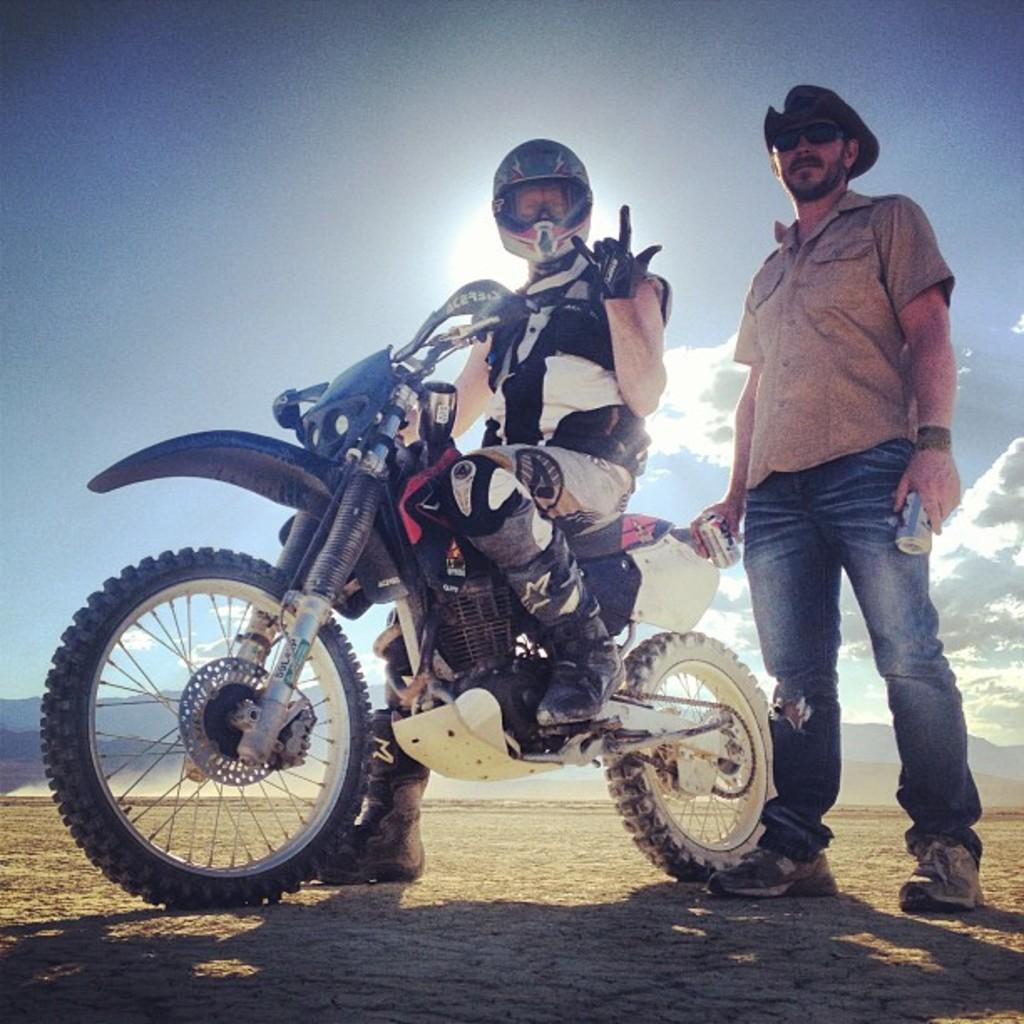Describe this image in one or two sentences. In this image, there is an outside view. There is person in the center of the image sitting on the bike. There is an another person on the right of the image standing and wearing clothes, shoes, sunglasses and hat. This person is holding tins with his hands. There is a sky at the top. 